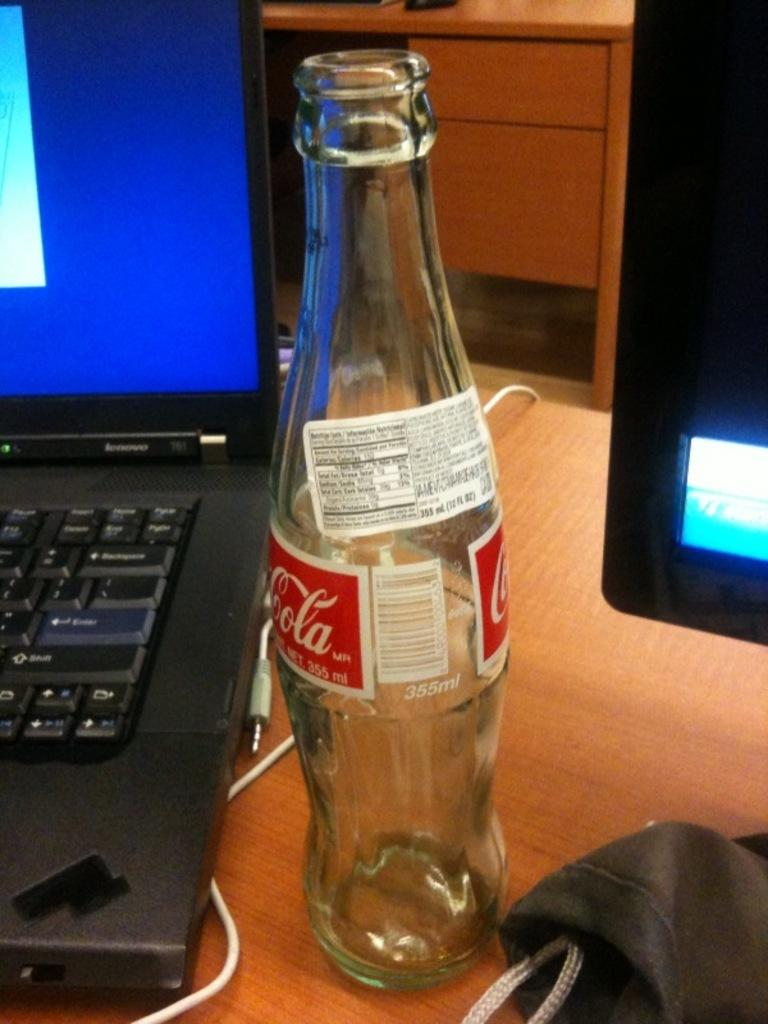<image>
Create a compact narrative representing the image presented. Clear glass bottle with the number 355 on the back. 